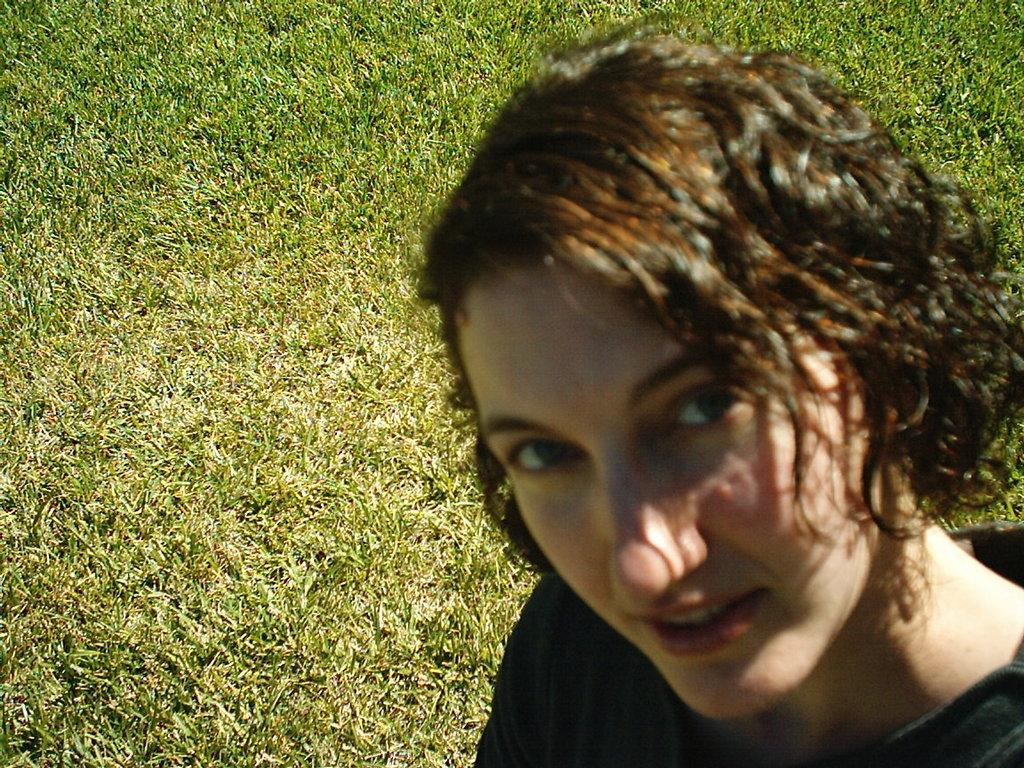Who is the main subject in the image? There is a woman in the image. Where is the woman located in the image? The woman is on the right side of the image. What type of environment is visible in the background of the image? There is grass in the background of the image. What type of map can be seen in the woman's hand in the image? There is no map present in the image; the woman's hands are not visible. 